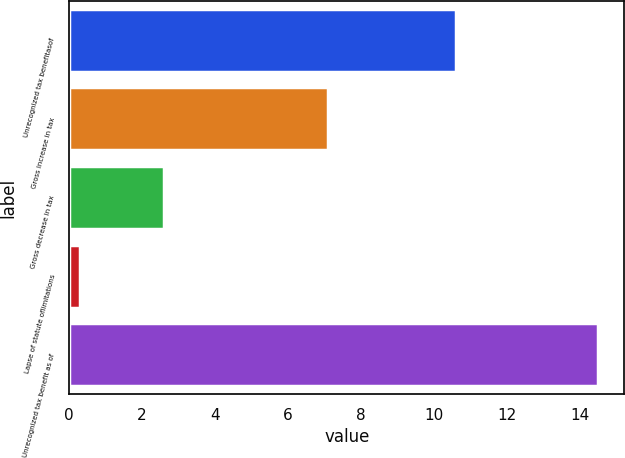Convert chart to OTSL. <chart><loc_0><loc_0><loc_500><loc_500><bar_chart><fcel>Unrecognized tax benefitasof<fcel>Gross increase in tax<fcel>Gross decrease in tax<fcel>Lapse of statute oflimitations<fcel>Unrecognized tax benefit as of<nl><fcel>10.6<fcel>7.1<fcel>2.6<fcel>0.3<fcel>14.5<nl></chart> 